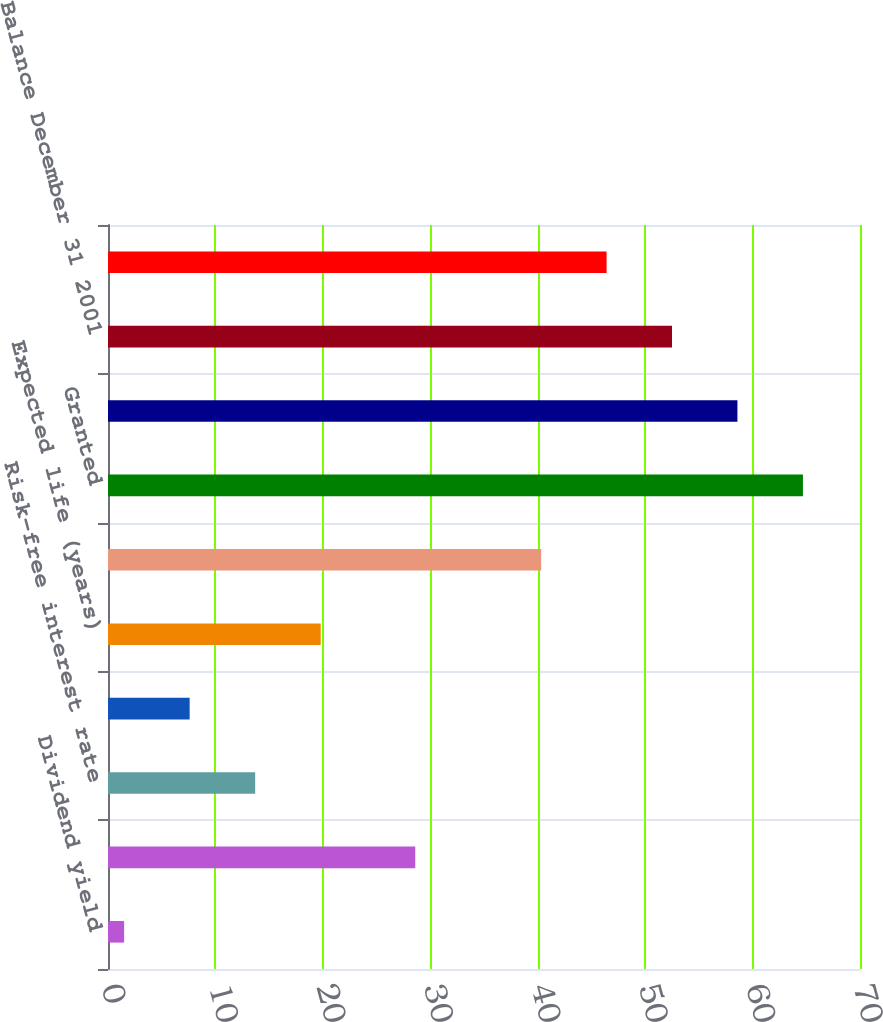Convert chart to OTSL. <chart><loc_0><loc_0><loc_500><loc_500><bar_chart><fcel>Dividend yield<fcel>Volatility<fcel>Risk-free interest rate<fcel>Assumed forfeiture rate<fcel>Expected life (years)<fcel>Balance December 31 2000<fcel>Granted<fcel>Lapsed<fcel>Balance December 31 2001<fcel>Balance December 31 2002<nl><fcel>1.5<fcel>28.6<fcel>13.7<fcel>7.6<fcel>19.8<fcel>40.32<fcel>64.69<fcel>58.59<fcel>52.5<fcel>46.41<nl></chart> 